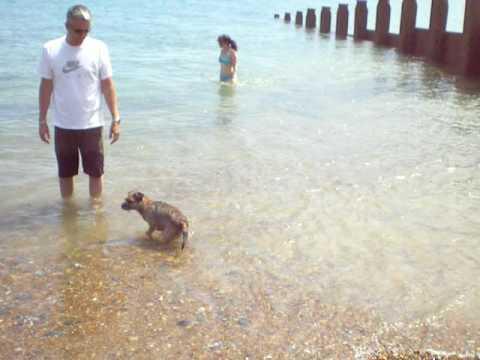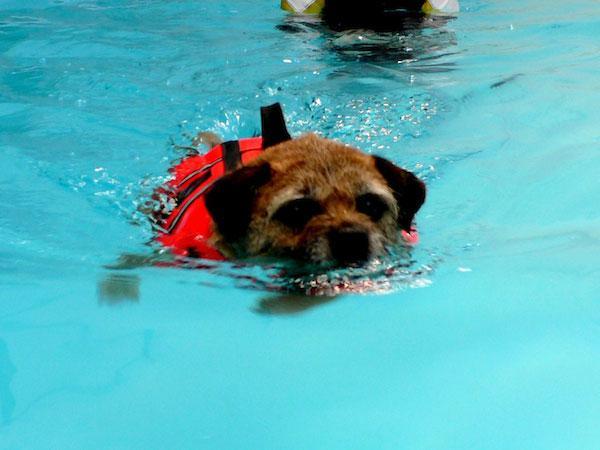The first image is the image on the left, the second image is the image on the right. Given the left and right images, does the statement "A dog is in the water with a man." hold true? Answer yes or no. Yes. The first image is the image on the left, the second image is the image on the right. Considering the images on both sides, is "There is a human in the water with at least one dog in the picture on the left." valid? Answer yes or no. Yes. 